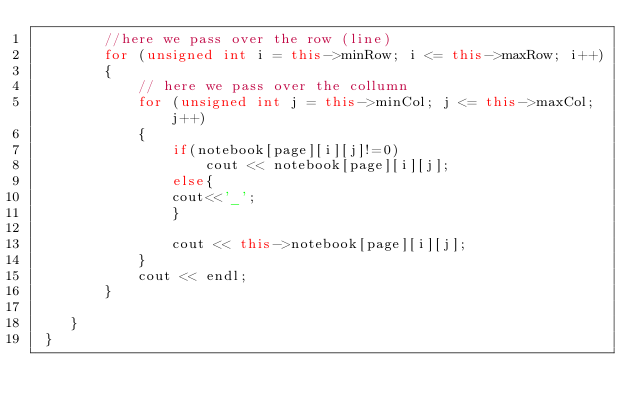Convert code to text. <code><loc_0><loc_0><loc_500><loc_500><_C++_>        //here we pass over the row (line)
        for (unsigned int i = this->minRow; i <= this->maxRow; i++) 
        {
            // here we pass over the collumn
            for (unsigned int j = this->minCol; j <= this->maxCol; j++) 
            {
                if(notebook[page][i][j]!=0)
                    cout << notebook[page][i][j];
                else{
                cout<<'_';
                }
                
                cout << this->notebook[page][i][j];
            }
            cout << endl;
        }
    
    }
 }
</code> 